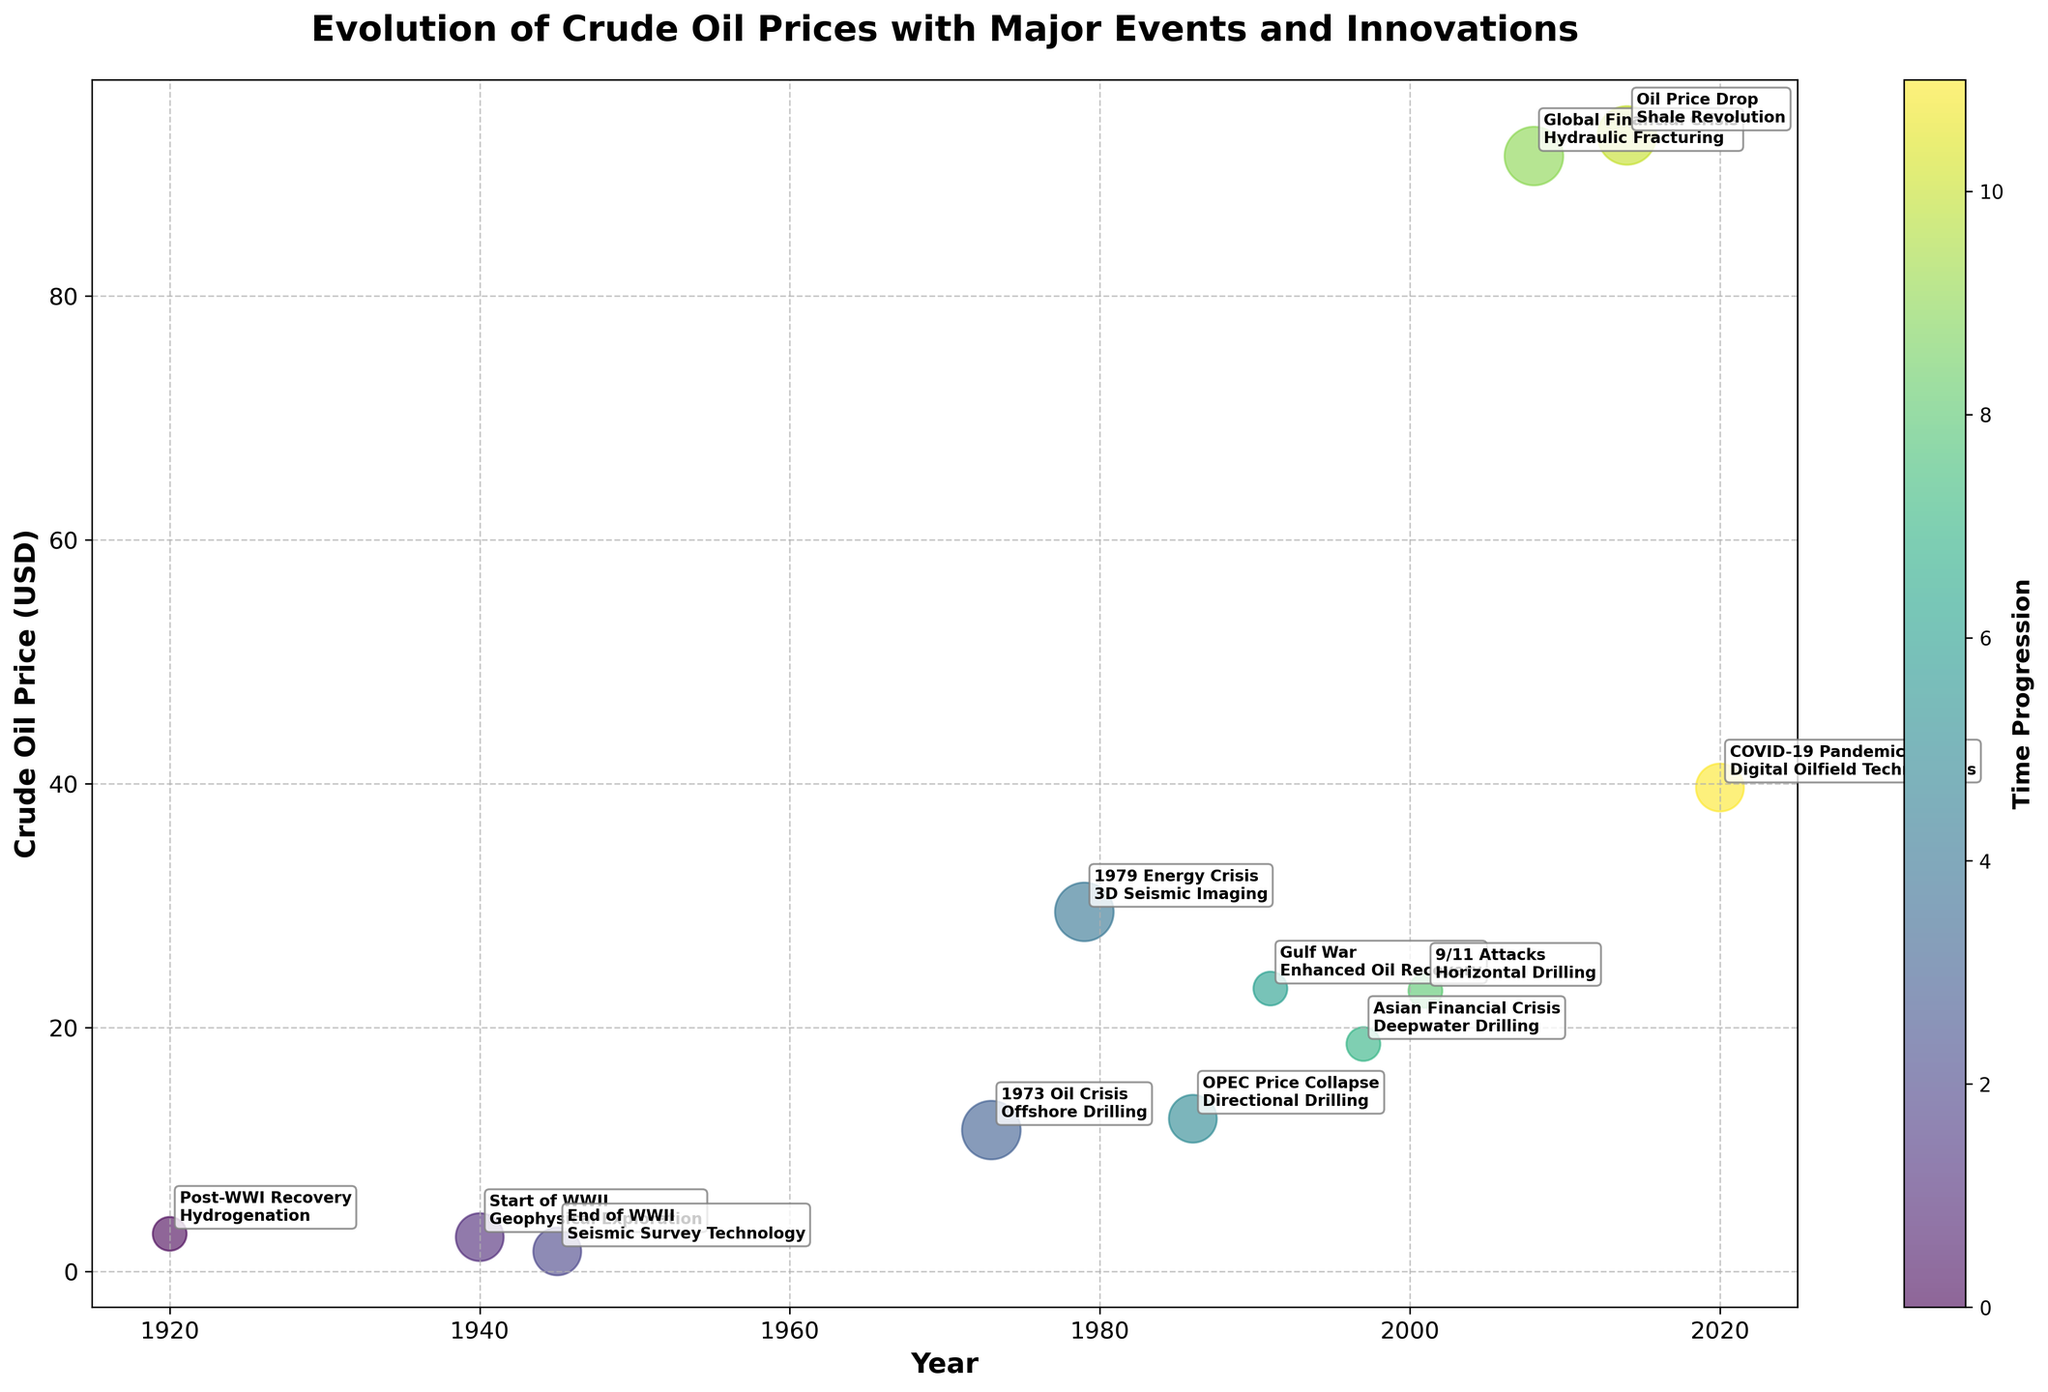What is the title of the figure? The title is usually found at the top of the figure, in this case, it is stated in the code within the set_title method.
Answer: Evolution of Crude Oil Prices with Major Events and Innovations How many major economic events and innovations are marked on the bubble chart? Count the number of unique data points annotated in the figure. There are 12 years listed in the data, so there must be 12 annotations.
Answer: 12 What is the highest crude oil price recorded in the figure? Look for the data point with the highest value on the y-axis labeled "Crude Oil Price (USD)". The highest value in the data provided is 93.17 in 2014.
Answer: 93.17 USD Which event corresponds to the highest bubble size, and what is the associated innovation? The highest impact level "Very High" corresponds to the largest bubble size, which can be checked by looking at the visual size of the bubbles and cross-referencing with the events: 1973 Oil Crisis, 1979 Energy Crisis, Global Financial Crisis, and 2014 Oil Price Drop.
Answer: 1973 Oil Crisis, Offshore Drilling (one example among the largest bubbles) What was the crude oil price in 1940, and what major event occurred at that time? Locate the year 1940 on the x-axis and find the corresponding y-axis value and annotation. It was 2.80 USD, and the event was the Start of WWII.
Answer: 2.80 USD, Start of WWII Compare the crude oil prices during the Global Financial Crisis in 2008 and the Oil Price Drop in 2014. Which was higher? Identify and compare the y-axis values for the years 2008 and 2014. In 2008, the price was 91.48 USD, and in 2014, the price was 93.17 USD.
Answer: 2014 Considering the bubbles with "Very High" impact, calculate the average crude oil price for these events. First, identify the events with "Very High" impact: 1973 Oil Crisis, 1979 Energy Crisis, Global Financial Crisis, and 2014 Oil Price Drop. Their prices are: 11.58, 29.48, 91.48, and 93.17. Sum these prices: 11.58 + 29.48 + 91.48 + 93.17 = 225.71. The average is 225.71 / 4 = 56.43.
Answer: 56.43 USD Which innovation is associated with the lowest crude oil price in the data, and what was the price? Locate the lowest value on the y-axis and check the associated annotation. The lowest price is 1.63 USD in 1945, associated with Seismic Survey Technology.
Answer: Seismic Survey Technology, 1.63 USD Between 1920 and 2020, during which major event did the crude oil price show the largest increase compared to the previous data point? Calculate the difference in crude oil prices between consecutive years and find the largest increase. The largest increase is between 2001 and 2008: 91.48 - 23.00 = 68.48.
Answer: Global Financial Crisis 